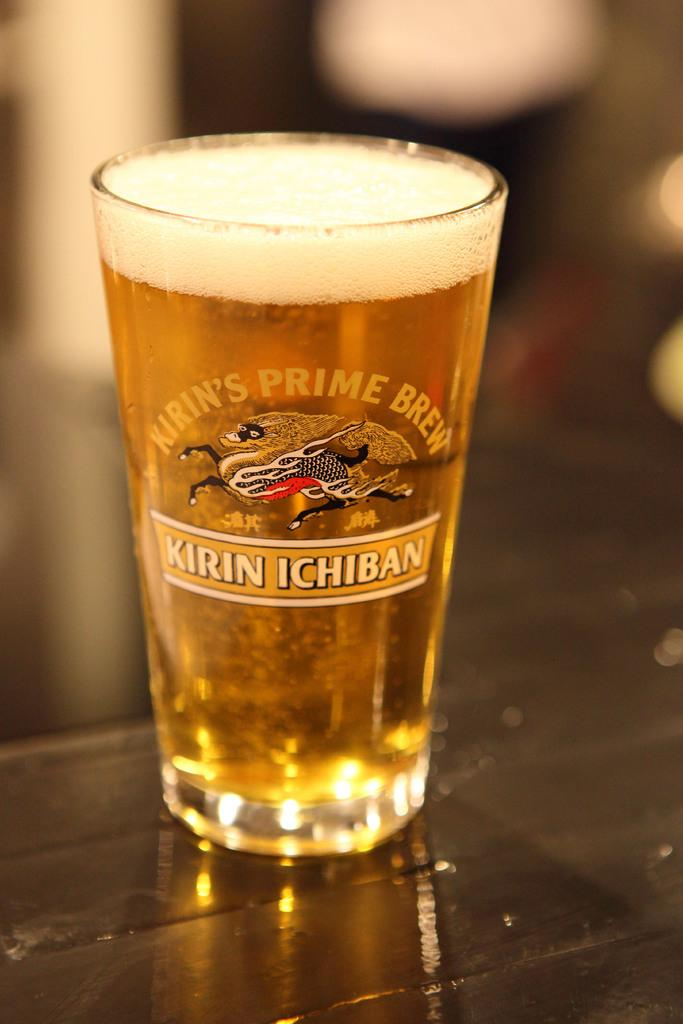What piece of furniture is present in the image? There is a table in the image. What object is placed on the table? There is a glass on the table. Can you describe the background of the image? The background of the image is blurred. What type of water can be seen flowing in the background of the image? There is no water visible in the image, as the background is blurred. Is there a carpenter working on the table in the image? There is no carpenter present in the image; it only features a table and a glass. 